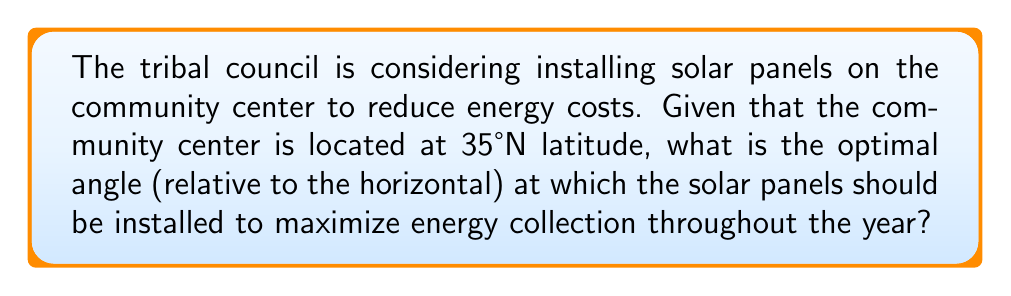Can you answer this question? To determine the optimal angle for solar panels, we can use a simple rule of thumb based on the latitude of the location. This rule states that the optimal tilt angle is approximately equal to the latitude of the location.

Let's break this down step-by-step:

1. We are given that the community center is located at 35°N latitude.

2. The optimal tilt angle $\theta$ can be calculated as:

   $$\theta = \text{latitude}$$

3. Substituting the given latitude:

   $$\theta = 35°$$

4. This angle is measured relative to the horizontal plane. To visualize this:

   [asy]
   import geometry;
   
   size(200);
   
   pair A = (0,0), B = (100,0), C = (100,70);
   draw(A--B--C--A);
   draw(B--(100,-20), dashed);
   
   label("Ground", (50,-10));
   label("Solar Panel", (80,35));
   label("35°", (110,20));
   
   draw(arc(B,20,0,35), Arrow);
   [/asy]

5. The reason this works is that it provides a good balance between summer and winter sun angles. In summer, when the sun is higher in the sky, it will still hit the panels at a good angle. In winter, when the sun is lower, the steeper angle helps to capture more of the available sunlight.

6. It's worth noting that this is a general rule, and slight adjustments might be made based on specific local conditions or if the goal is to optimize for a particular season.
Answer: 35° 